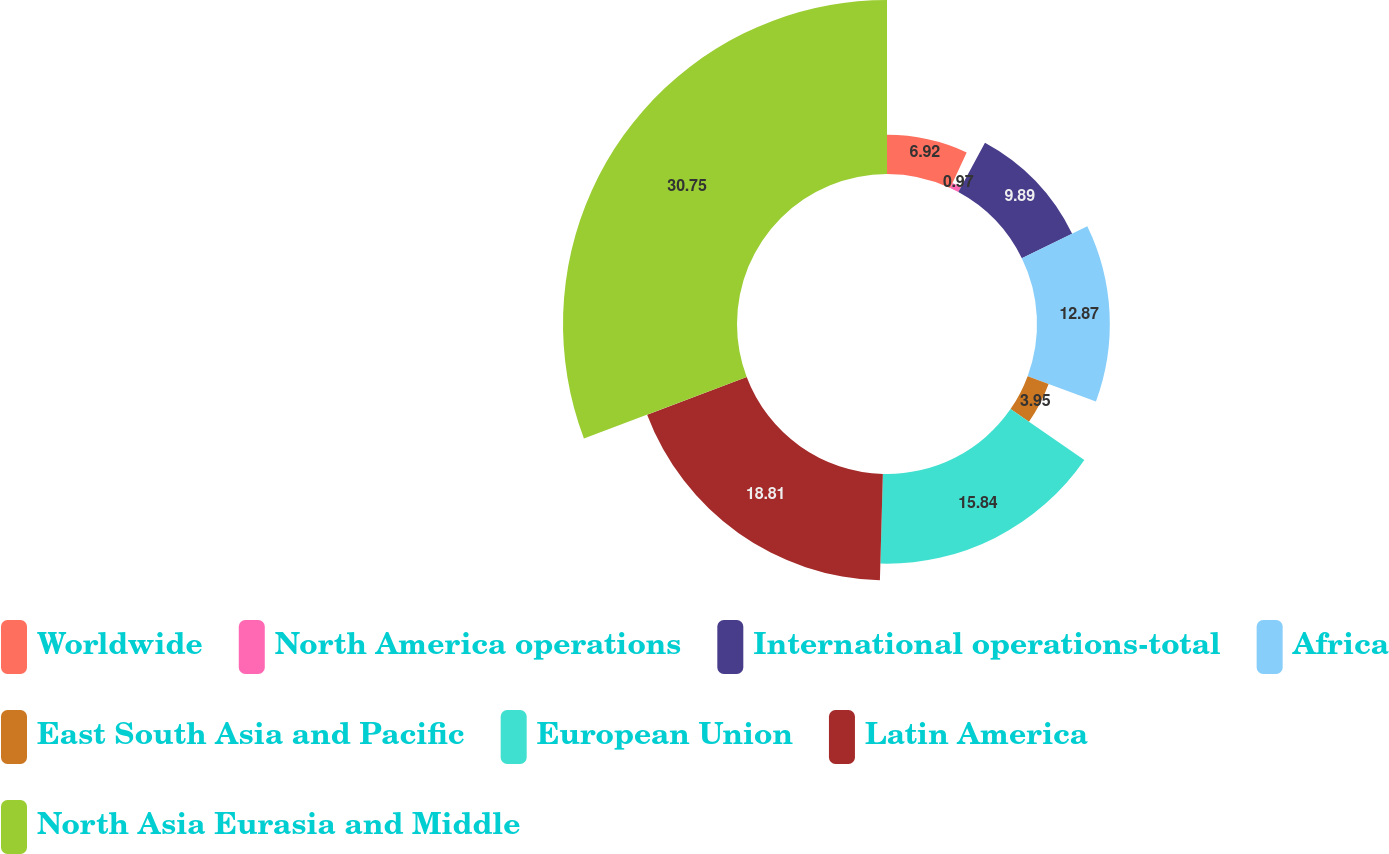Convert chart. <chart><loc_0><loc_0><loc_500><loc_500><pie_chart><fcel>Worldwide<fcel>North America operations<fcel>International operations-total<fcel>Africa<fcel>East South Asia and Pacific<fcel>European Union<fcel>Latin America<fcel>North Asia Eurasia and Middle<nl><fcel>6.92%<fcel>0.97%<fcel>9.89%<fcel>12.87%<fcel>3.95%<fcel>15.84%<fcel>18.81%<fcel>30.75%<nl></chart> 